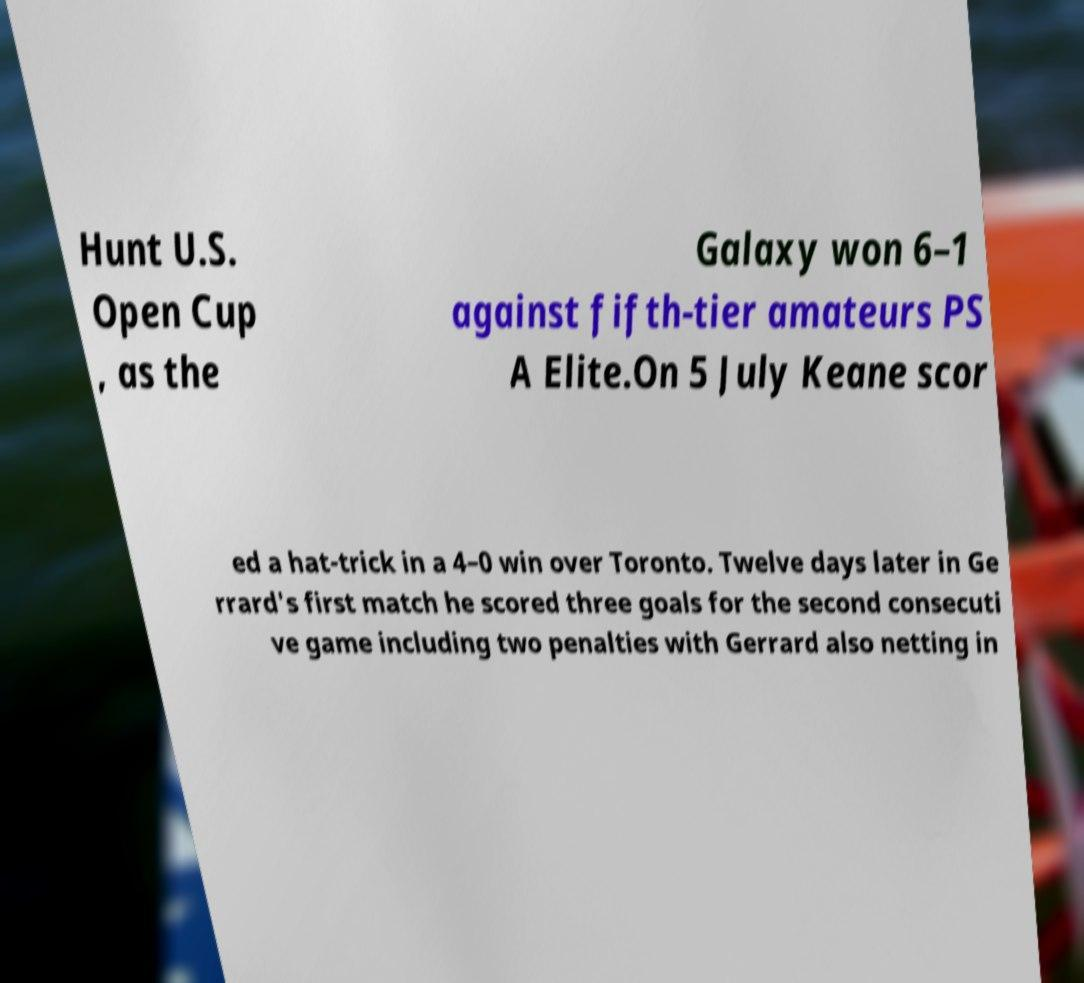Can you accurately transcribe the text from the provided image for me? Hunt U.S. Open Cup , as the Galaxy won 6–1 against fifth-tier amateurs PS A Elite.On 5 July Keane scor ed a hat-trick in a 4–0 win over Toronto. Twelve days later in Ge rrard's first match he scored three goals for the second consecuti ve game including two penalties with Gerrard also netting in 